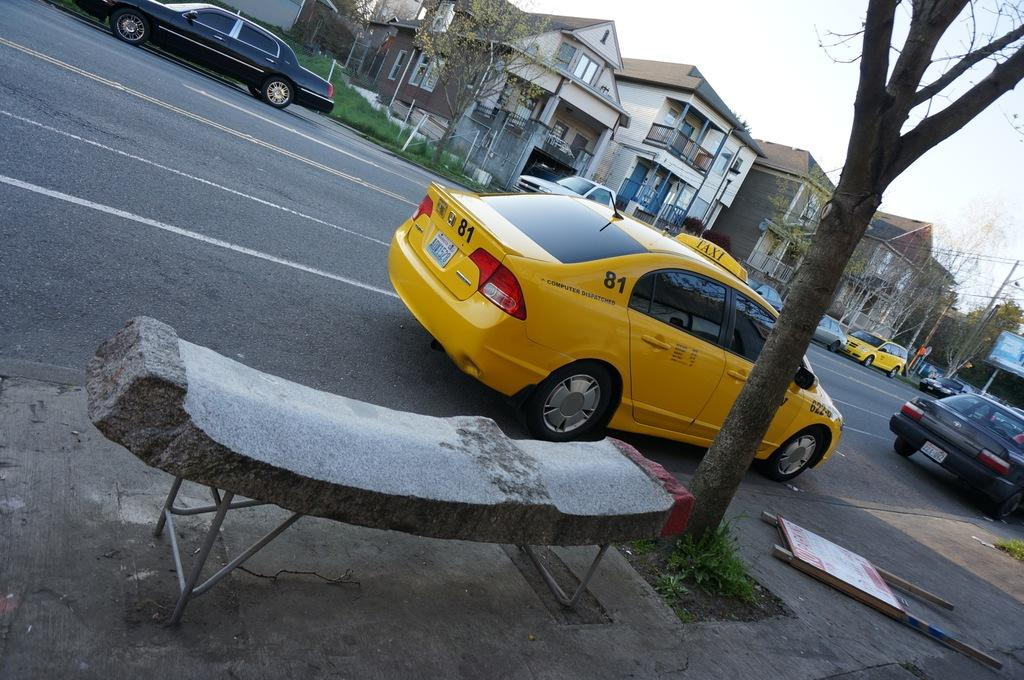<image>
Create a compact narrative representing the image presented. A yellow cab that has the numbers 81 on it. 